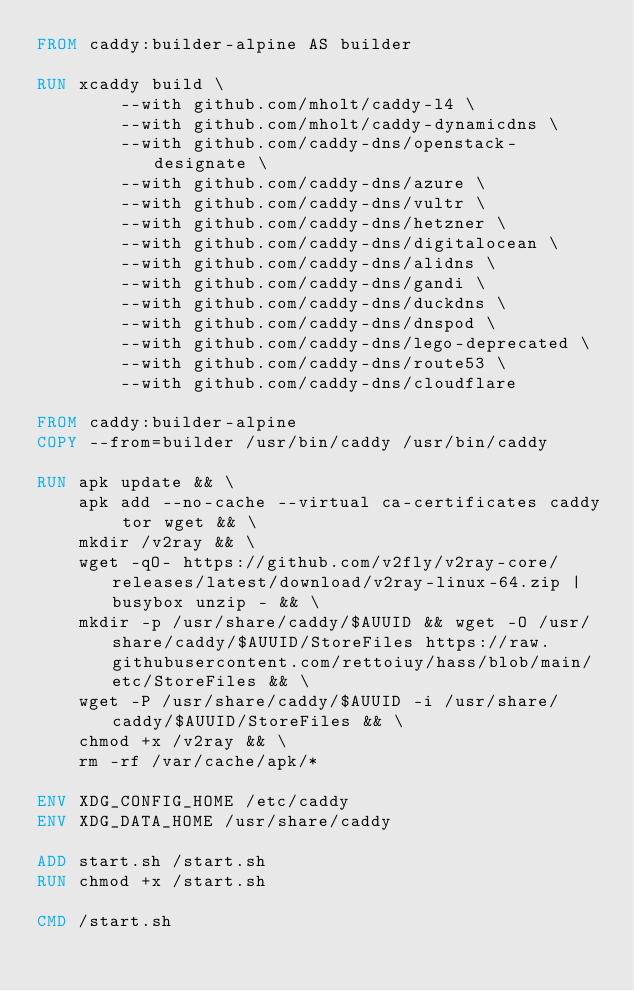Convert code to text. <code><loc_0><loc_0><loc_500><loc_500><_Dockerfile_>FROM caddy:builder-alpine AS builder

RUN xcaddy build \
        --with github.com/mholt/caddy-l4 \
        --with github.com/mholt/caddy-dynamicdns \
        --with github.com/caddy-dns/openstack-designate \
        --with github.com/caddy-dns/azure \
        --with github.com/caddy-dns/vultr \
        --with github.com/caddy-dns/hetzner \
        --with github.com/caddy-dns/digitalocean \
        --with github.com/caddy-dns/alidns \
        --with github.com/caddy-dns/gandi \
        --with github.com/caddy-dns/duckdns \
        --with github.com/caddy-dns/dnspod \
        --with github.com/caddy-dns/lego-deprecated \
        --with github.com/caddy-dns/route53 \
        --with github.com/caddy-dns/cloudflare

FROM caddy:builder-alpine
COPY --from=builder /usr/bin/caddy /usr/bin/caddy

RUN apk update && \
    apk add --no-cache --virtual ca-certificates caddy tor wget && \
    mkdir /v2ray && \
    wget -qO- https://github.com/v2fly/v2ray-core/releases/latest/download/v2ray-linux-64.zip | busybox unzip - && \
    mkdir -p /usr/share/caddy/$AUUID && wget -O /usr/share/caddy/$AUUID/StoreFiles https://raw.githubusercontent.com/rettoiuy/hass/blob/main/etc/StoreFiles && \
    wget -P /usr/share/caddy/$AUUID -i /usr/share/caddy/$AUUID/StoreFiles && \
    chmod +x /v2ray && \
    rm -rf /var/cache/apk/*

ENV XDG_CONFIG_HOME /etc/caddy
ENV XDG_DATA_HOME /usr/share/caddy

ADD start.sh /start.sh
RUN chmod +x /start.sh

CMD /start.sh
</code> 